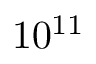Convert formula to latex. <formula><loc_0><loc_0><loc_500><loc_500>1 0 ^ { 1 1 }</formula> 